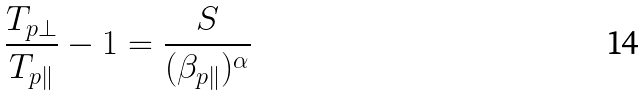<formula> <loc_0><loc_0><loc_500><loc_500>\frac { T _ { p \perp } } { T _ { p \| } } - 1 = \frac { S } { ( \beta _ { p \| } ) ^ { \alpha } }</formula> 